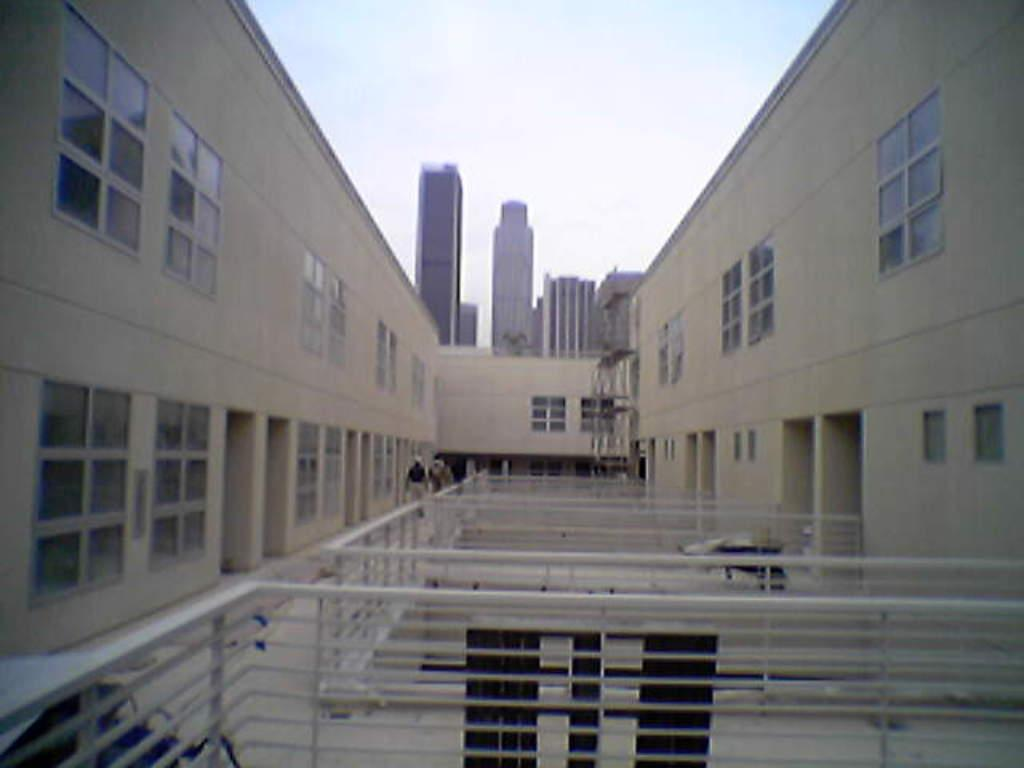What type of structures can be seen in the image? There are buildings in the image. Are there any living beings present in the image? Yes, there are people in the image. What can be seen in the distance in the image? The sky is visible in the background of the image. What type of barrier is present in the image? There is a white color fence in the image. What type of metal can be seen in the image? There is no metal present in the image. How many bananas are being held by the people in the image? There are no bananas visible in the image. 